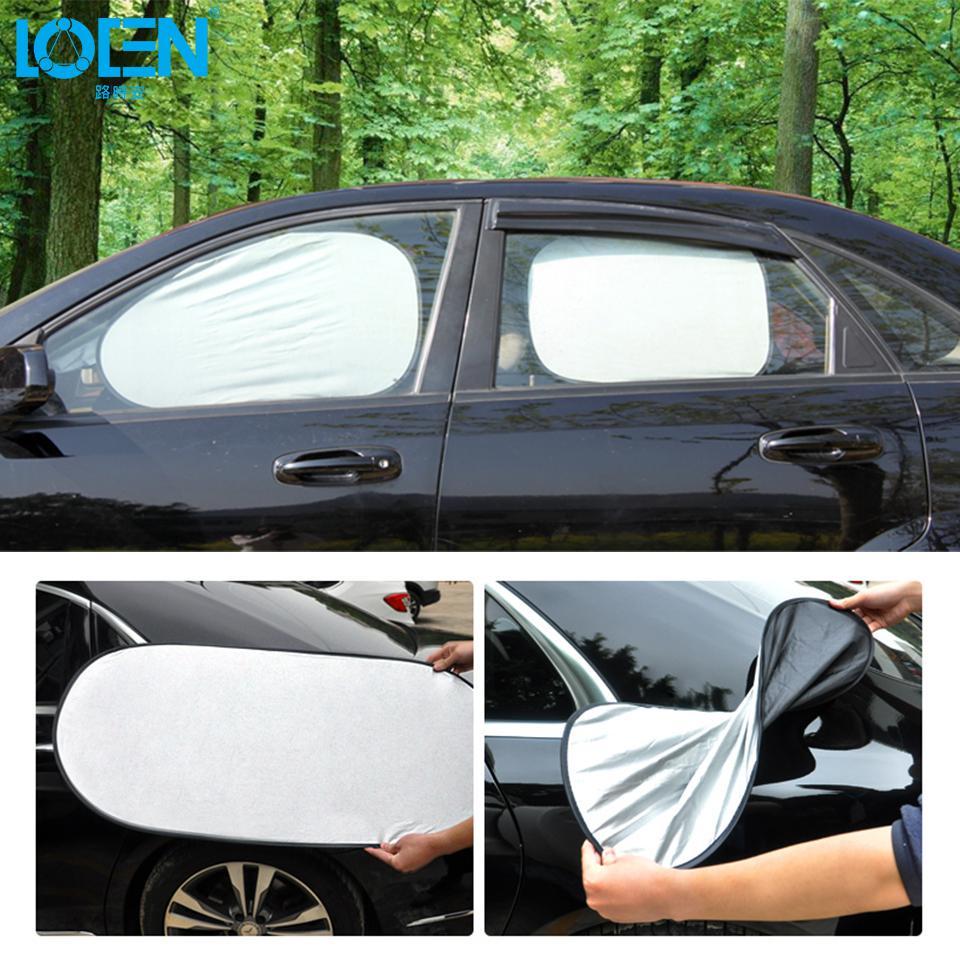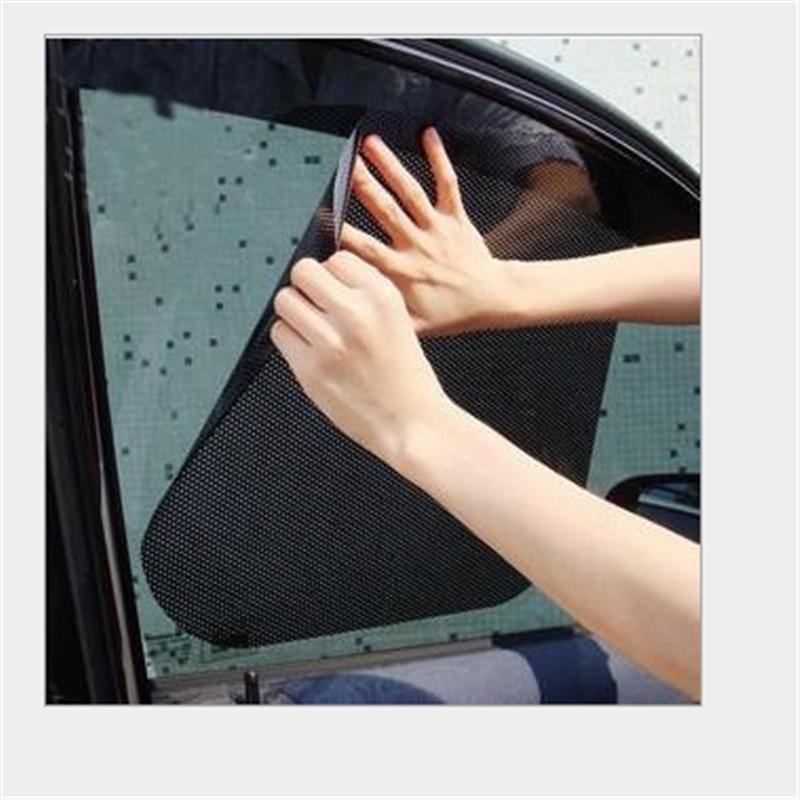The first image is the image on the left, the second image is the image on the right. Evaluate the accuracy of this statement regarding the images: "There are a pair of hands with the right hand splayed out and the left balled up.". Is it true? Answer yes or no. Yes. 